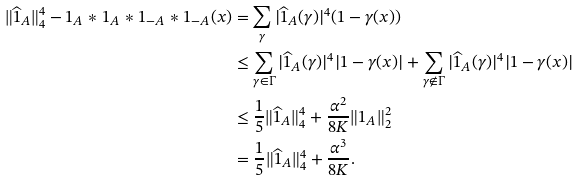Convert formula to latex. <formula><loc_0><loc_0><loc_500><loc_500>\| \widehat { 1 } _ { A } \| _ { 4 } ^ { 4 } - 1 _ { A } \ast 1 _ { A } \ast 1 _ { - A } \ast 1 _ { - A } ( x ) & = \sum _ { \gamma } | \widehat { 1 } _ { A } ( \gamma ) | ^ { 4 } ( 1 - \gamma ( x ) ) \\ & \leq \sum _ { \gamma \in \Gamma } | \widehat { 1 } _ { A } ( \gamma ) | ^ { 4 } | 1 - \gamma ( x ) | + \sum _ { \gamma \notin \Gamma } | \widehat { 1 } _ { A } ( \gamma ) | ^ { 4 } | 1 - \gamma ( x ) | \\ & \leq \frac { 1 } { 5 } \| \widehat { 1 } _ { A } \| _ { 4 } ^ { 4 } + \frac { \alpha ^ { 2 } } { 8 K } \| 1 _ { A } \| _ { 2 } ^ { 2 } \\ & = \frac { 1 } { 5 } \| \widehat { 1 } _ { A } \| _ { 4 } ^ { 4 } + \frac { \alpha ^ { 3 } } { 8 K } .</formula> 